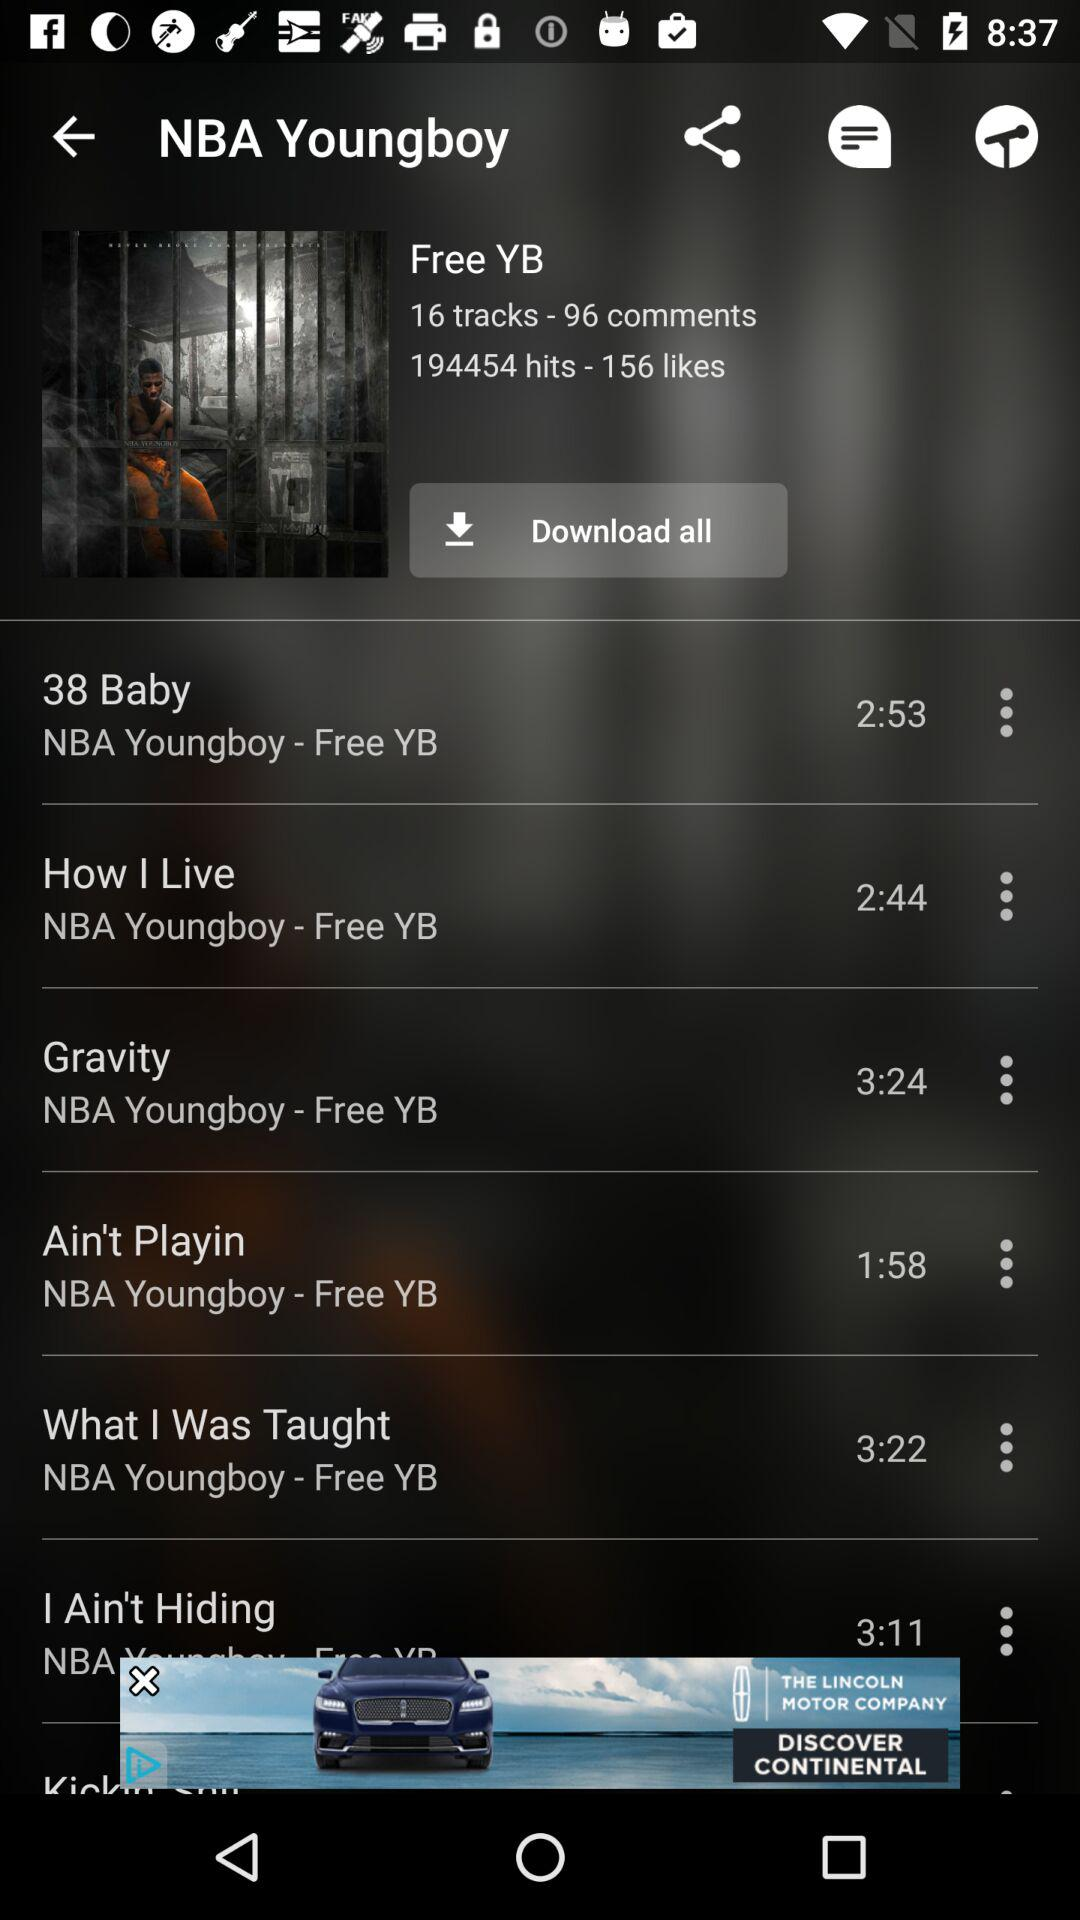Which song has the shortest duration? The song is "Ain't Playin". 